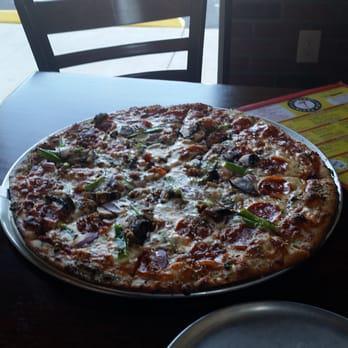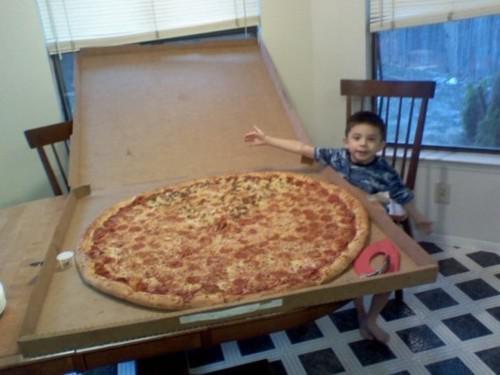The first image is the image on the left, the second image is the image on the right. Analyze the images presented: Is the assertion "There are two whole pizzas." valid? Answer yes or no. Yes. The first image is the image on the left, the second image is the image on the right. Examine the images to the left and right. Is the description "The left image features a round pizza on a round metal tray, and the right image features a large round pizza in an open cardboard box with a person on the right of it." accurate? Answer yes or no. Yes. 